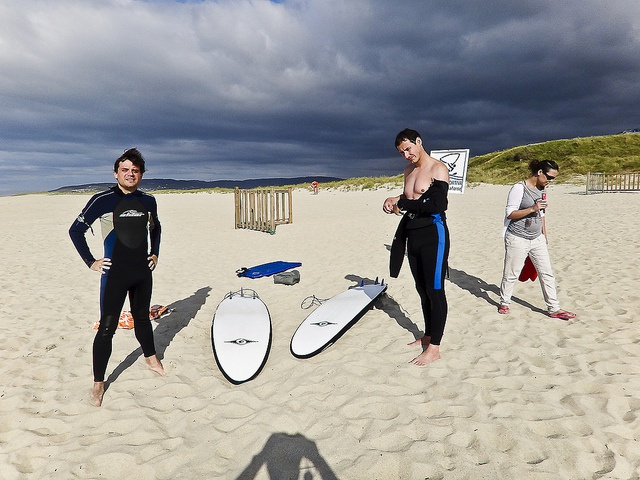Describe the objects in this image and their specific colors. I can see people in lightgray, black, darkgray, and tan tones, people in lightgray, black, tan, and blue tones, people in lightgray, darkgray, black, and gray tones, surfboard in lightgray, white, black, darkgray, and gray tones, and surfboard in lightgray, black, darkgray, and gray tones in this image. 